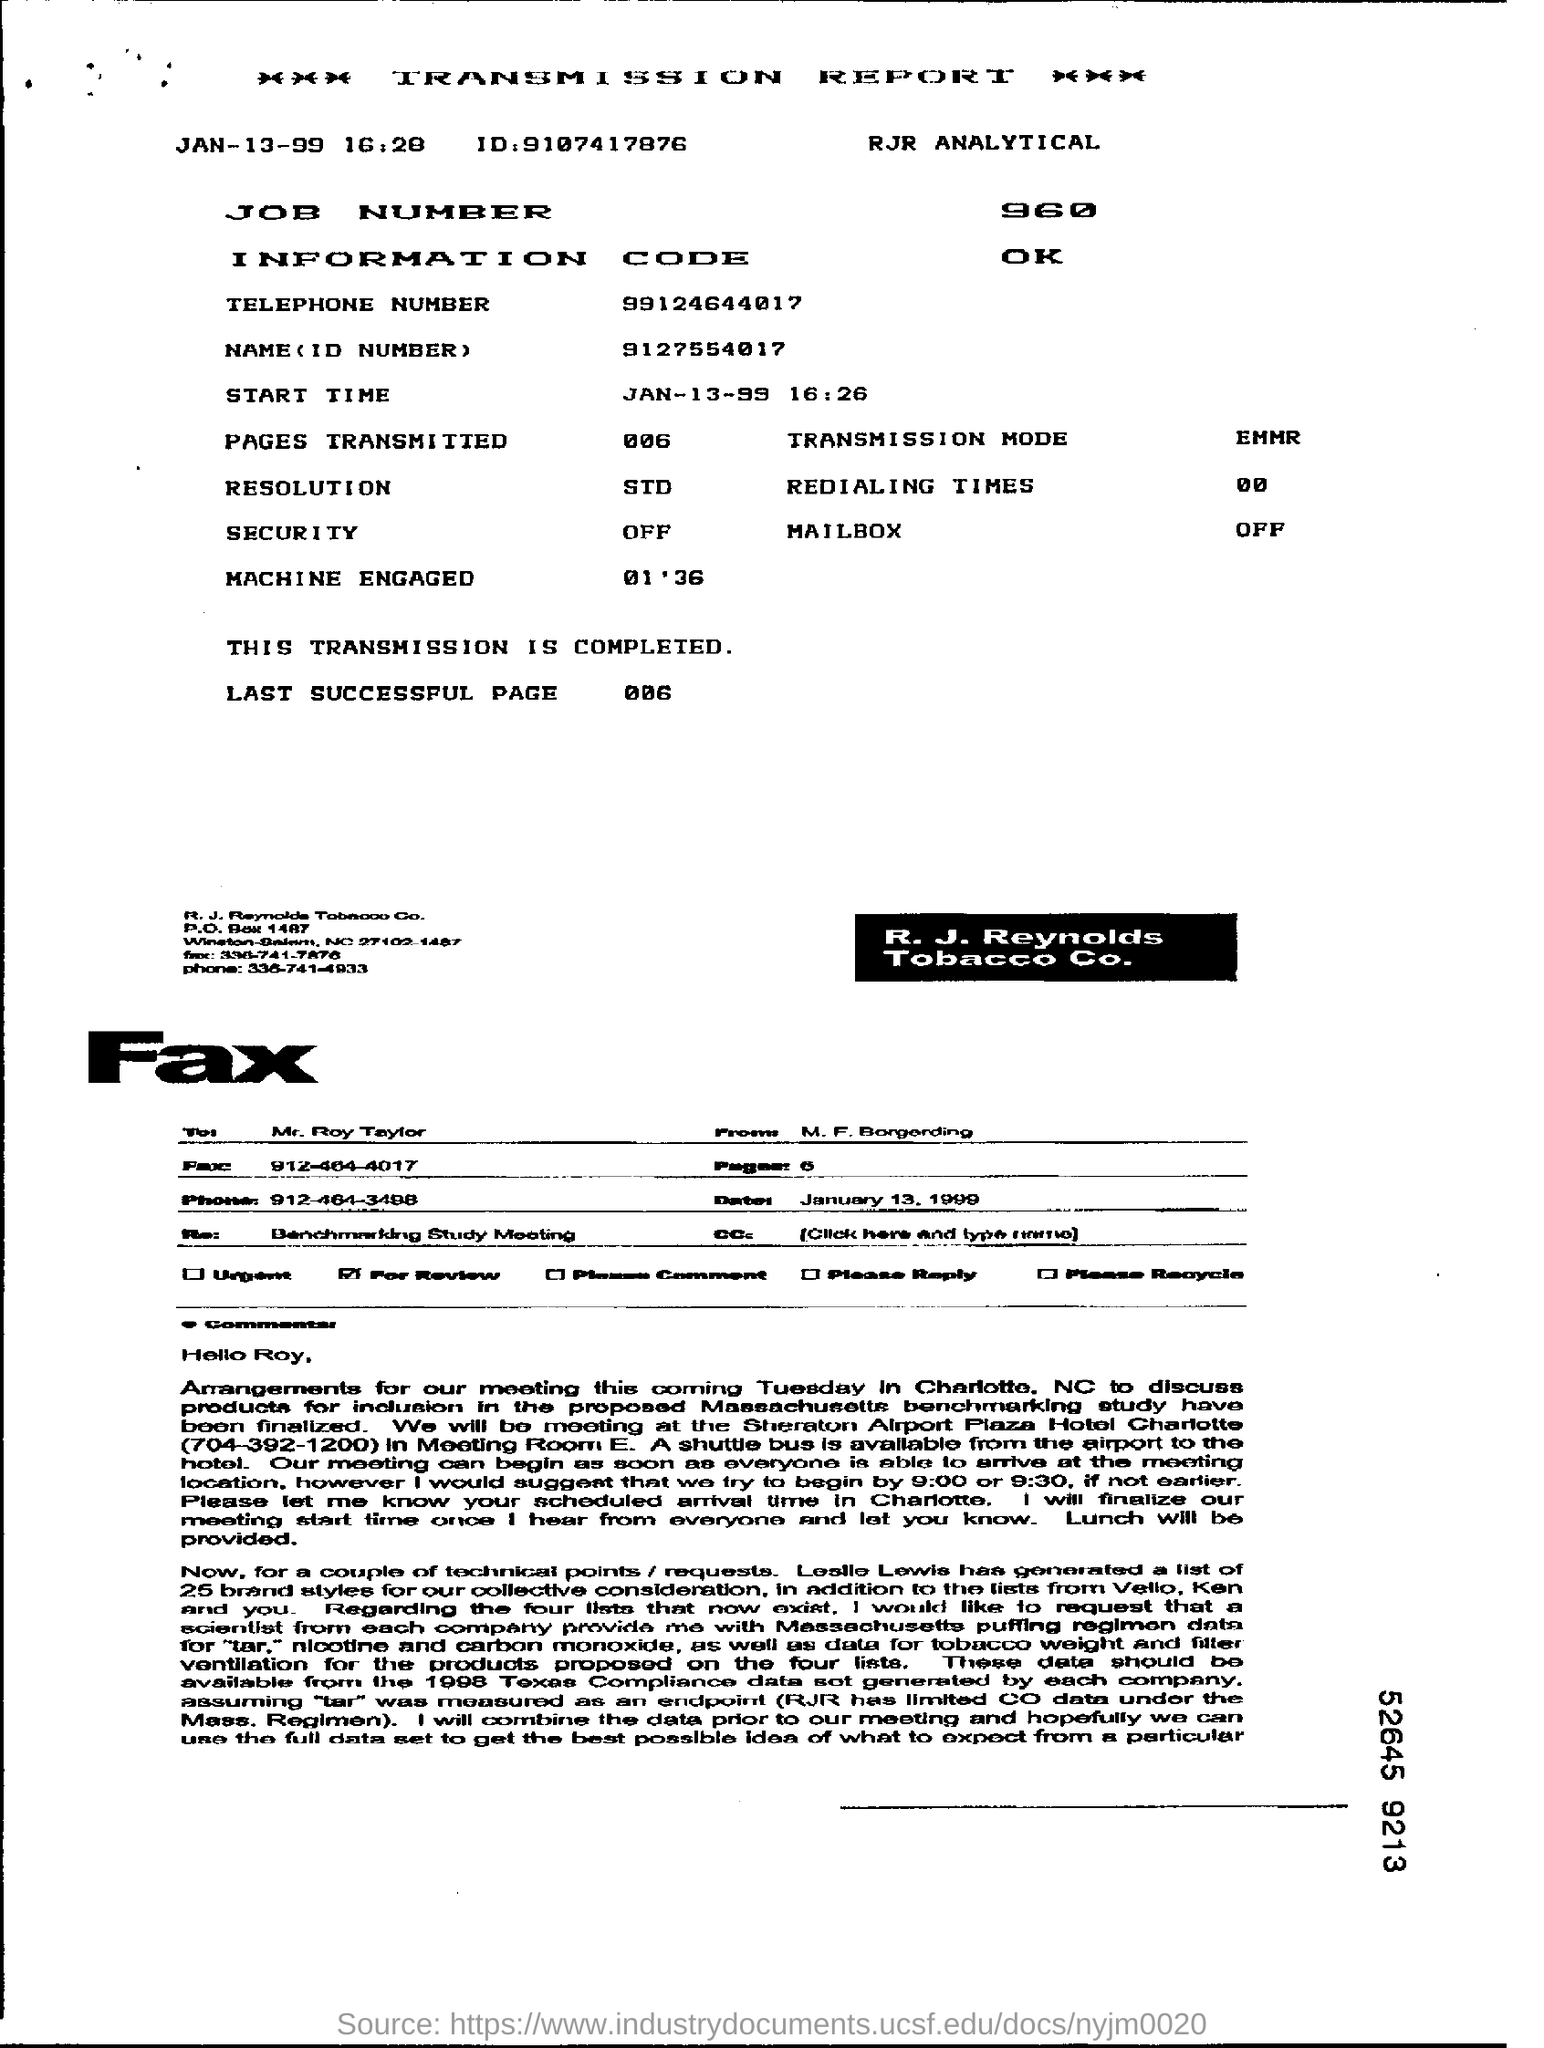Which Report is this ?
Offer a very short reply. Transmission Report. What is the Job number ?
Provide a succinct answer. 960. What is the Information Code ?
Your answer should be very brief. OK. What is the Start time ?
Give a very brief answer. 16:26. 